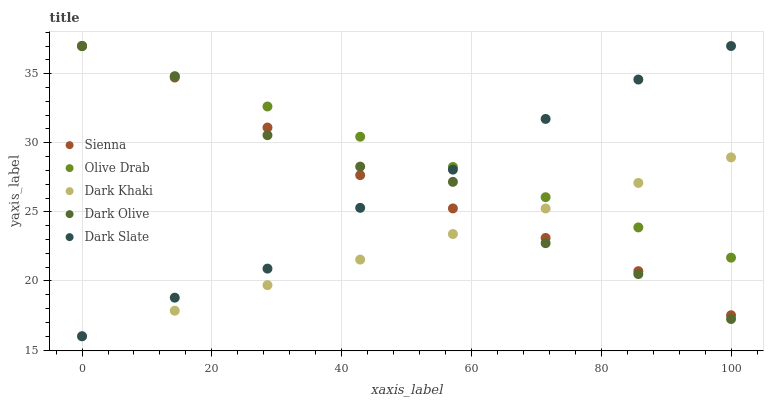Does Dark Khaki have the minimum area under the curve?
Answer yes or no. Yes. Does Olive Drab have the maximum area under the curve?
Answer yes or no. Yes. Does Dark Olive have the minimum area under the curve?
Answer yes or no. No. Does Dark Olive have the maximum area under the curve?
Answer yes or no. No. Is Dark Khaki the smoothest?
Answer yes or no. Yes. Is Dark Olive the roughest?
Answer yes or no. Yes. Is Dark Olive the smoothest?
Answer yes or no. No. Is Dark Khaki the roughest?
Answer yes or no. No. Does Dark Khaki have the lowest value?
Answer yes or no. Yes. Does Dark Olive have the lowest value?
Answer yes or no. No. Does Dark Slate have the highest value?
Answer yes or no. Yes. Does Dark Khaki have the highest value?
Answer yes or no. No. Does Dark Khaki intersect Dark Olive?
Answer yes or no. Yes. Is Dark Khaki less than Dark Olive?
Answer yes or no. No. Is Dark Khaki greater than Dark Olive?
Answer yes or no. No. 